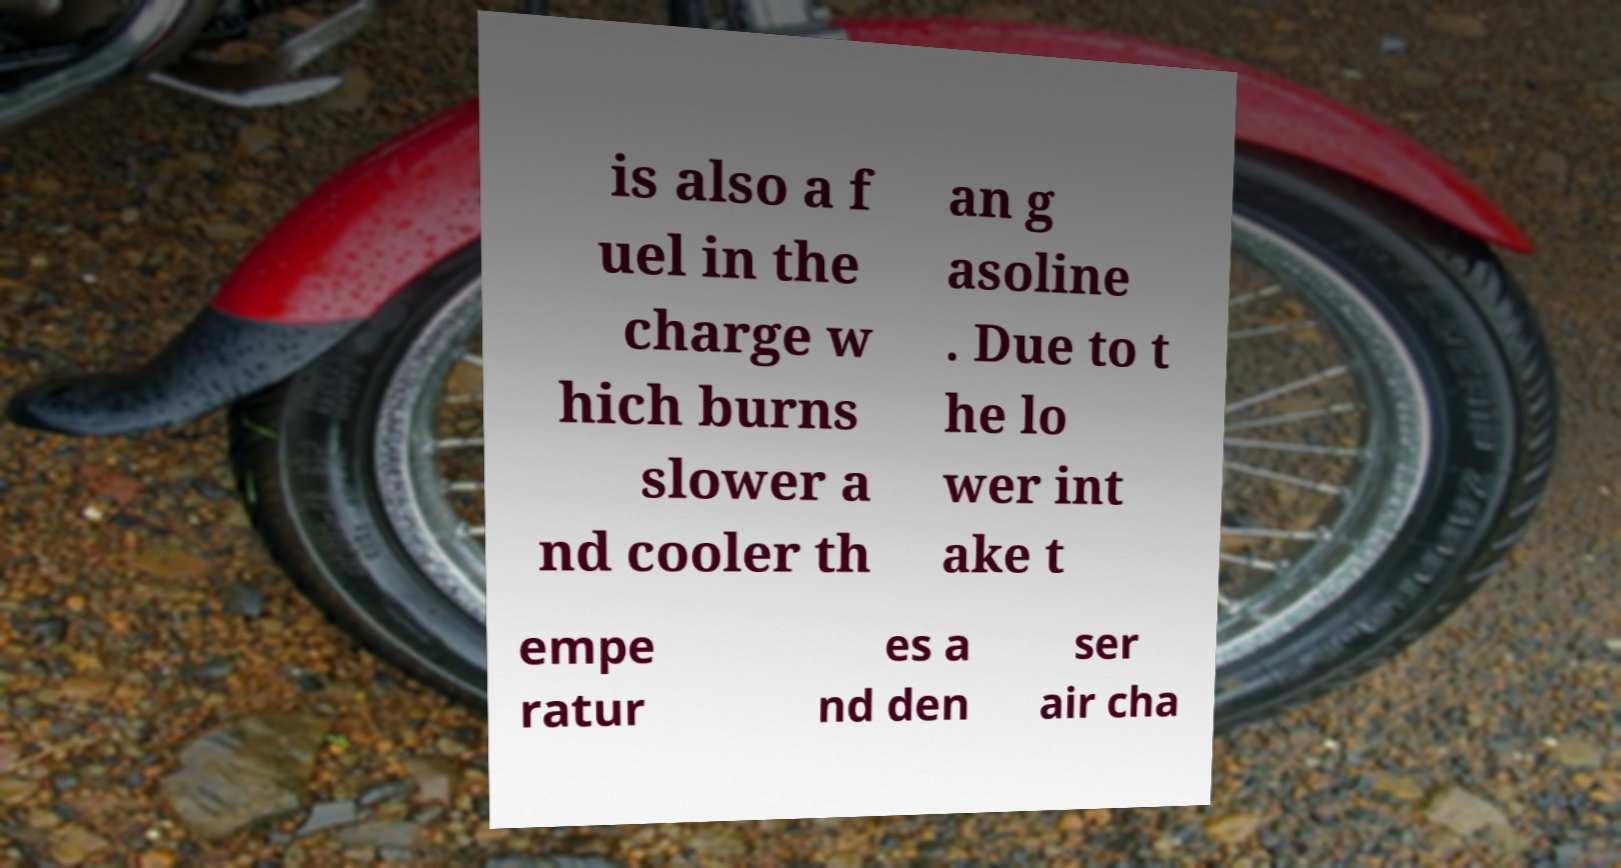I need the written content from this picture converted into text. Can you do that? is also a f uel in the charge w hich burns slower a nd cooler th an g asoline . Due to t he lo wer int ake t empe ratur es a nd den ser air cha 